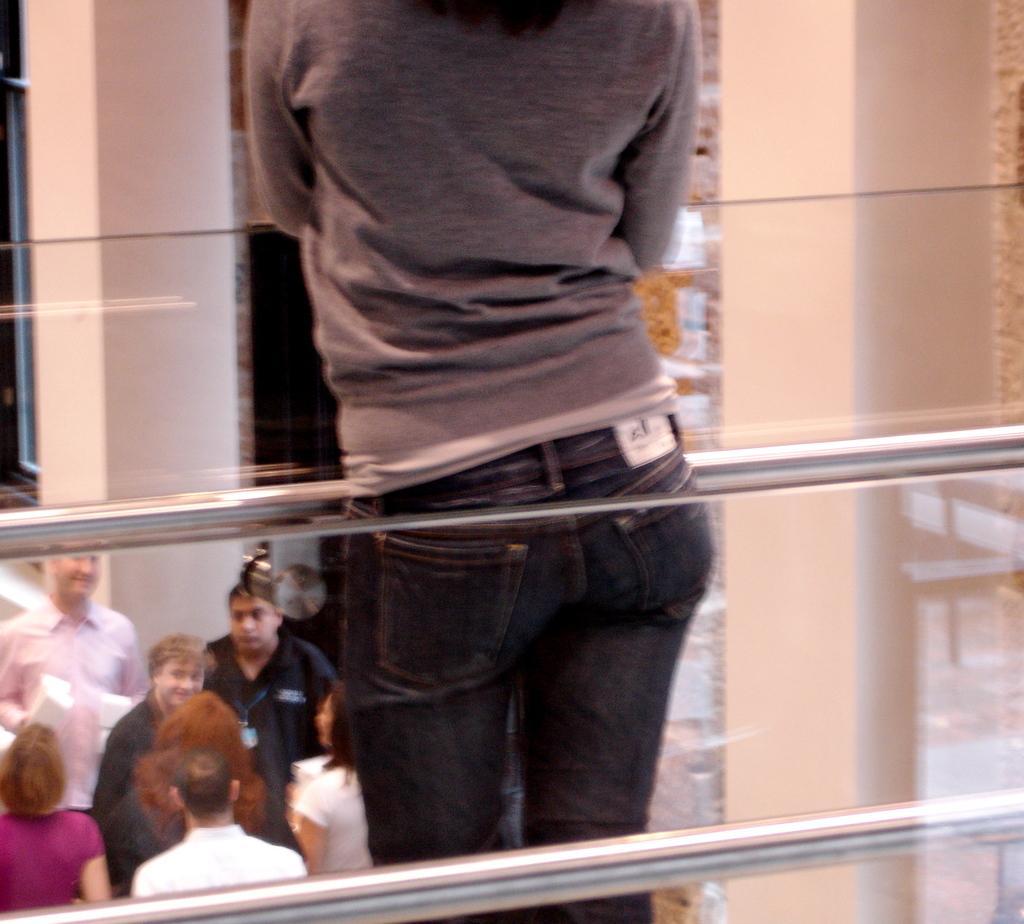In one or two sentences, can you explain what this image depicts? In this image I can see group of people. In front the person is wearing gray color shirt and I can see few rods. In the background the wall is in cream color. 